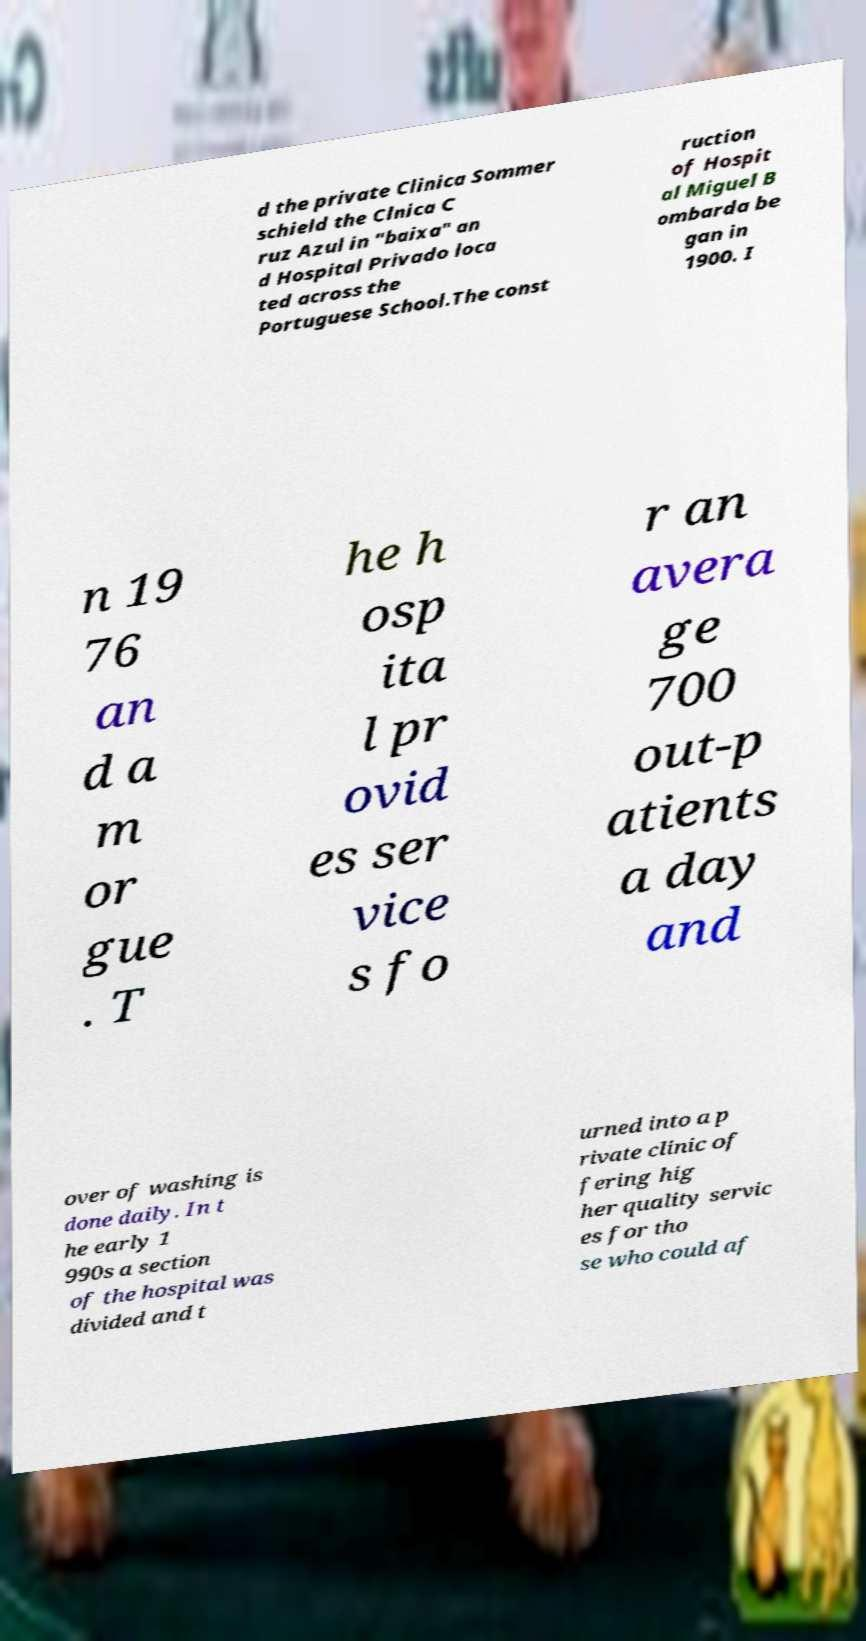For documentation purposes, I need the text within this image transcribed. Could you provide that? d the private Clinica Sommer schield the Clnica C ruz Azul in "baixa" an d Hospital Privado loca ted across the Portuguese School.The const ruction of Hospit al Miguel B ombarda be gan in 1900. I n 19 76 an d a m or gue . T he h osp ita l pr ovid es ser vice s fo r an avera ge 700 out-p atients a day and over of washing is done daily. In t he early 1 990s a section of the hospital was divided and t urned into a p rivate clinic of fering hig her quality servic es for tho se who could af 